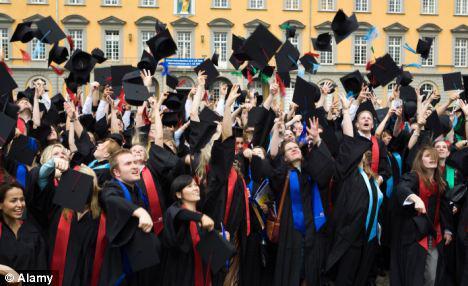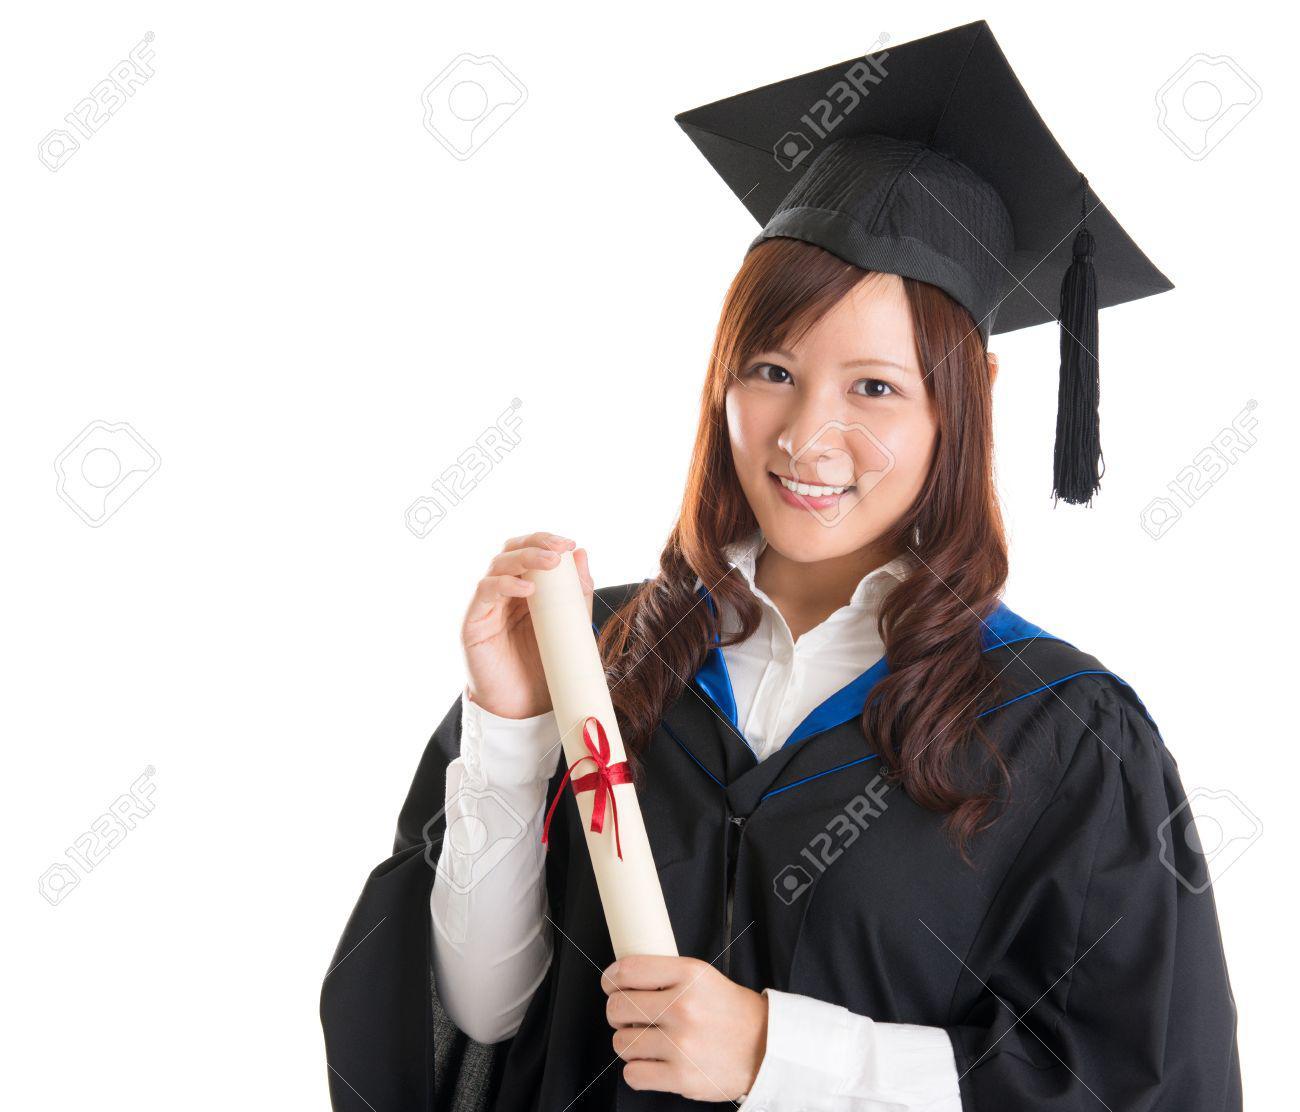The first image is the image on the left, the second image is the image on the right. Analyze the images presented: Is the assertion "There are more people posing in their caps and gowns in the image on the right." valid? Answer yes or no. No. The first image is the image on the left, the second image is the image on the right. Examine the images to the left and right. Is the description "All graduates wear dark caps and robes, and the left image shows a smiling black graduate alone in the foreground." accurate? Answer yes or no. No. 